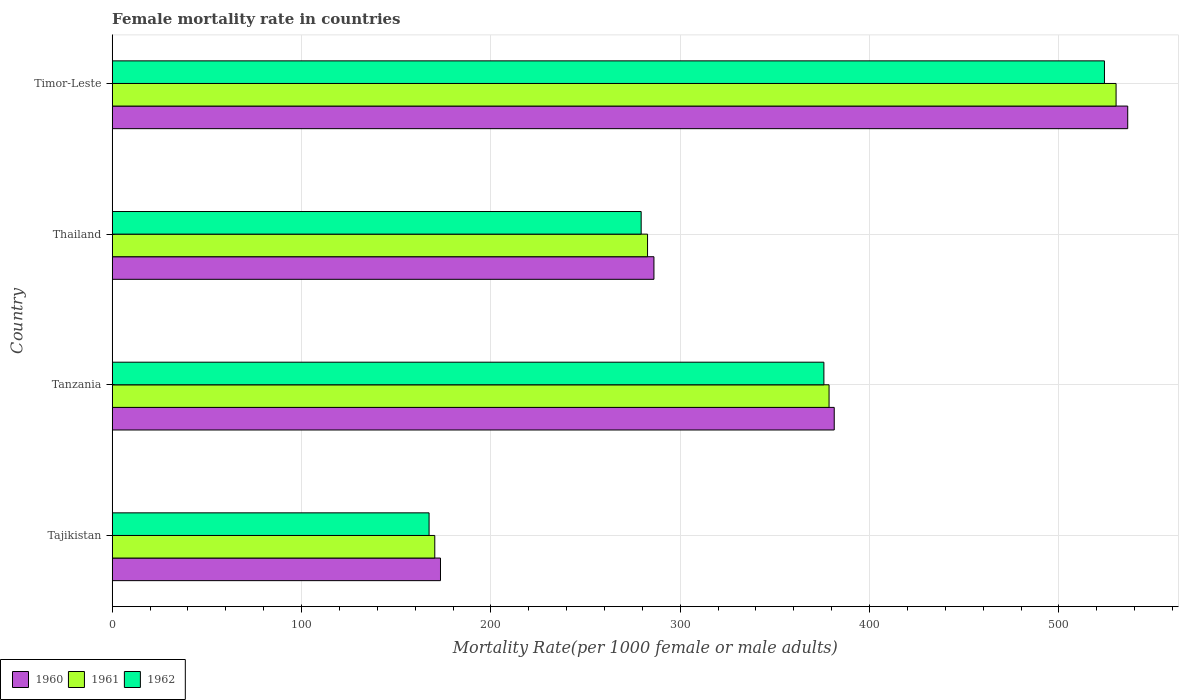How many bars are there on the 2nd tick from the bottom?
Your response must be concise. 3. What is the label of the 2nd group of bars from the top?
Ensure brevity in your answer.  Thailand. What is the female mortality rate in 1962 in Tajikistan?
Provide a short and direct response. 167.34. Across all countries, what is the maximum female mortality rate in 1962?
Your answer should be compact. 524.04. Across all countries, what is the minimum female mortality rate in 1961?
Ensure brevity in your answer.  170.36. In which country was the female mortality rate in 1962 maximum?
Ensure brevity in your answer.  Timor-Leste. In which country was the female mortality rate in 1962 minimum?
Offer a very short reply. Tajikistan. What is the total female mortality rate in 1961 in the graph?
Keep it short and to the point. 1361.87. What is the difference between the female mortality rate in 1962 in Thailand and that in Timor-Leste?
Provide a short and direct response. -244.68. What is the difference between the female mortality rate in 1962 in Timor-Leste and the female mortality rate in 1961 in Tajikistan?
Your answer should be compact. 353.68. What is the average female mortality rate in 1960 per country?
Offer a terse response. 344.28. What is the difference between the female mortality rate in 1962 and female mortality rate in 1960 in Timor-Leste?
Offer a very short reply. -12.29. In how many countries, is the female mortality rate in 1962 greater than 520 ?
Ensure brevity in your answer.  1. What is the ratio of the female mortality rate in 1960 in Tajikistan to that in Timor-Leste?
Provide a succinct answer. 0.32. Is the female mortality rate in 1961 in Tajikistan less than that in Thailand?
Offer a very short reply. Yes. What is the difference between the highest and the second highest female mortality rate in 1961?
Your answer should be compact. 151.59. What is the difference between the highest and the lowest female mortality rate in 1960?
Provide a succinct answer. 362.96. What does the 3rd bar from the top in Tajikistan represents?
Offer a very short reply. 1960. Is it the case that in every country, the sum of the female mortality rate in 1960 and female mortality rate in 1961 is greater than the female mortality rate in 1962?
Provide a succinct answer. Yes. How many countries are there in the graph?
Provide a short and direct response. 4. Are the values on the major ticks of X-axis written in scientific E-notation?
Your answer should be very brief. No. Does the graph contain any zero values?
Make the answer very short. No. How many legend labels are there?
Provide a short and direct response. 3. What is the title of the graph?
Provide a succinct answer. Female mortality rate in countries. What is the label or title of the X-axis?
Offer a very short reply. Mortality Rate(per 1000 female or male adults). What is the Mortality Rate(per 1000 female or male adults) in 1960 in Tajikistan?
Provide a short and direct response. 173.37. What is the Mortality Rate(per 1000 female or male adults) in 1961 in Tajikistan?
Your response must be concise. 170.36. What is the Mortality Rate(per 1000 female or male adults) of 1962 in Tajikistan?
Offer a terse response. 167.34. What is the Mortality Rate(per 1000 female or male adults) in 1960 in Tanzania?
Offer a very short reply. 381.33. What is the Mortality Rate(per 1000 female or male adults) of 1961 in Tanzania?
Your answer should be compact. 378.6. What is the Mortality Rate(per 1000 female or male adults) of 1962 in Tanzania?
Offer a very short reply. 375.87. What is the Mortality Rate(per 1000 female or male adults) of 1960 in Thailand?
Give a very brief answer. 286.1. What is the Mortality Rate(per 1000 female or male adults) of 1961 in Thailand?
Make the answer very short. 282.73. What is the Mortality Rate(per 1000 female or male adults) of 1962 in Thailand?
Your answer should be compact. 279.36. What is the Mortality Rate(per 1000 female or male adults) of 1960 in Timor-Leste?
Offer a terse response. 536.33. What is the Mortality Rate(per 1000 female or male adults) of 1961 in Timor-Leste?
Your response must be concise. 530.18. What is the Mortality Rate(per 1000 female or male adults) of 1962 in Timor-Leste?
Provide a short and direct response. 524.04. Across all countries, what is the maximum Mortality Rate(per 1000 female or male adults) in 1960?
Offer a very short reply. 536.33. Across all countries, what is the maximum Mortality Rate(per 1000 female or male adults) in 1961?
Give a very brief answer. 530.18. Across all countries, what is the maximum Mortality Rate(per 1000 female or male adults) of 1962?
Your answer should be very brief. 524.04. Across all countries, what is the minimum Mortality Rate(per 1000 female or male adults) of 1960?
Keep it short and to the point. 173.37. Across all countries, what is the minimum Mortality Rate(per 1000 female or male adults) in 1961?
Provide a succinct answer. 170.36. Across all countries, what is the minimum Mortality Rate(per 1000 female or male adults) of 1962?
Keep it short and to the point. 167.34. What is the total Mortality Rate(per 1000 female or male adults) in 1960 in the graph?
Your response must be concise. 1377.14. What is the total Mortality Rate(per 1000 female or male adults) in 1961 in the graph?
Your answer should be very brief. 1361.87. What is the total Mortality Rate(per 1000 female or male adults) of 1962 in the graph?
Keep it short and to the point. 1346.6. What is the difference between the Mortality Rate(per 1000 female or male adults) of 1960 in Tajikistan and that in Tanzania?
Make the answer very short. -207.96. What is the difference between the Mortality Rate(per 1000 female or male adults) of 1961 in Tajikistan and that in Tanzania?
Keep it short and to the point. -208.24. What is the difference between the Mortality Rate(per 1000 female or male adults) of 1962 in Tajikistan and that in Tanzania?
Ensure brevity in your answer.  -208.52. What is the difference between the Mortality Rate(per 1000 female or male adults) of 1960 in Tajikistan and that in Thailand?
Keep it short and to the point. -112.73. What is the difference between the Mortality Rate(per 1000 female or male adults) in 1961 in Tajikistan and that in Thailand?
Provide a succinct answer. -112.37. What is the difference between the Mortality Rate(per 1000 female or male adults) of 1962 in Tajikistan and that in Thailand?
Ensure brevity in your answer.  -112.02. What is the difference between the Mortality Rate(per 1000 female or male adults) in 1960 in Tajikistan and that in Timor-Leste?
Offer a terse response. -362.96. What is the difference between the Mortality Rate(per 1000 female or male adults) in 1961 in Tajikistan and that in Timor-Leste?
Your answer should be very brief. -359.83. What is the difference between the Mortality Rate(per 1000 female or male adults) of 1962 in Tajikistan and that in Timor-Leste?
Provide a succinct answer. -356.7. What is the difference between the Mortality Rate(per 1000 female or male adults) in 1960 in Tanzania and that in Thailand?
Your answer should be compact. 95.23. What is the difference between the Mortality Rate(per 1000 female or male adults) in 1961 in Tanzania and that in Thailand?
Ensure brevity in your answer.  95.87. What is the difference between the Mortality Rate(per 1000 female or male adults) in 1962 in Tanzania and that in Thailand?
Provide a succinct answer. 96.51. What is the difference between the Mortality Rate(per 1000 female or male adults) of 1960 in Tanzania and that in Timor-Leste?
Provide a succinct answer. -155. What is the difference between the Mortality Rate(per 1000 female or male adults) of 1961 in Tanzania and that in Timor-Leste?
Your response must be concise. -151.59. What is the difference between the Mortality Rate(per 1000 female or male adults) in 1962 in Tanzania and that in Timor-Leste?
Ensure brevity in your answer.  -148.18. What is the difference between the Mortality Rate(per 1000 female or male adults) of 1960 in Thailand and that in Timor-Leste?
Your answer should be very brief. -250.23. What is the difference between the Mortality Rate(per 1000 female or male adults) in 1961 in Thailand and that in Timor-Leste?
Your response must be concise. -247.45. What is the difference between the Mortality Rate(per 1000 female or male adults) in 1962 in Thailand and that in Timor-Leste?
Offer a very short reply. -244.68. What is the difference between the Mortality Rate(per 1000 female or male adults) of 1960 in Tajikistan and the Mortality Rate(per 1000 female or male adults) of 1961 in Tanzania?
Ensure brevity in your answer.  -205.22. What is the difference between the Mortality Rate(per 1000 female or male adults) in 1960 in Tajikistan and the Mortality Rate(per 1000 female or male adults) in 1962 in Tanzania?
Keep it short and to the point. -202.49. What is the difference between the Mortality Rate(per 1000 female or male adults) of 1961 in Tajikistan and the Mortality Rate(per 1000 female or male adults) of 1962 in Tanzania?
Your answer should be very brief. -205.51. What is the difference between the Mortality Rate(per 1000 female or male adults) of 1960 in Tajikistan and the Mortality Rate(per 1000 female or male adults) of 1961 in Thailand?
Ensure brevity in your answer.  -109.36. What is the difference between the Mortality Rate(per 1000 female or male adults) of 1960 in Tajikistan and the Mortality Rate(per 1000 female or male adults) of 1962 in Thailand?
Give a very brief answer. -105.98. What is the difference between the Mortality Rate(per 1000 female or male adults) in 1961 in Tajikistan and the Mortality Rate(per 1000 female or male adults) in 1962 in Thailand?
Keep it short and to the point. -109. What is the difference between the Mortality Rate(per 1000 female or male adults) of 1960 in Tajikistan and the Mortality Rate(per 1000 female or male adults) of 1961 in Timor-Leste?
Your answer should be very brief. -356.81. What is the difference between the Mortality Rate(per 1000 female or male adults) in 1960 in Tajikistan and the Mortality Rate(per 1000 female or male adults) in 1962 in Timor-Leste?
Offer a very short reply. -350.67. What is the difference between the Mortality Rate(per 1000 female or male adults) of 1961 in Tajikistan and the Mortality Rate(per 1000 female or male adults) of 1962 in Timor-Leste?
Provide a short and direct response. -353.68. What is the difference between the Mortality Rate(per 1000 female or male adults) of 1960 in Tanzania and the Mortality Rate(per 1000 female or male adults) of 1961 in Thailand?
Your response must be concise. 98.6. What is the difference between the Mortality Rate(per 1000 female or male adults) in 1960 in Tanzania and the Mortality Rate(per 1000 female or male adults) in 1962 in Thailand?
Your response must be concise. 101.97. What is the difference between the Mortality Rate(per 1000 female or male adults) in 1961 in Tanzania and the Mortality Rate(per 1000 female or male adults) in 1962 in Thailand?
Make the answer very short. 99.24. What is the difference between the Mortality Rate(per 1000 female or male adults) of 1960 in Tanzania and the Mortality Rate(per 1000 female or male adults) of 1961 in Timor-Leste?
Provide a short and direct response. -148.85. What is the difference between the Mortality Rate(per 1000 female or male adults) in 1960 in Tanzania and the Mortality Rate(per 1000 female or male adults) in 1962 in Timor-Leste?
Provide a succinct answer. -142.71. What is the difference between the Mortality Rate(per 1000 female or male adults) in 1961 in Tanzania and the Mortality Rate(per 1000 female or male adults) in 1962 in Timor-Leste?
Make the answer very short. -145.44. What is the difference between the Mortality Rate(per 1000 female or male adults) in 1960 in Thailand and the Mortality Rate(per 1000 female or male adults) in 1961 in Timor-Leste?
Provide a short and direct response. -244.08. What is the difference between the Mortality Rate(per 1000 female or male adults) of 1960 in Thailand and the Mortality Rate(per 1000 female or male adults) of 1962 in Timor-Leste?
Keep it short and to the point. -237.94. What is the difference between the Mortality Rate(per 1000 female or male adults) in 1961 in Thailand and the Mortality Rate(per 1000 female or male adults) in 1962 in Timor-Leste?
Give a very brief answer. -241.31. What is the average Mortality Rate(per 1000 female or male adults) of 1960 per country?
Ensure brevity in your answer.  344.28. What is the average Mortality Rate(per 1000 female or male adults) in 1961 per country?
Give a very brief answer. 340.47. What is the average Mortality Rate(per 1000 female or male adults) in 1962 per country?
Keep it short and to the point. 336.65. What is the difference between the Mortality Rate(per 1000 female or male adults) in 1960 and Mortality Rate(per 1000 female or male adults) in 1961 in Tajikistan?
Keep it short and to the point. 3.02. What is the difference between the Mortality Rate(per 1000 female or male adults) in 1960 and Mortality Rate(per 1000 female or male adults) in 1962 in Tajikistan?
Offer a very short reply. 6.03. What is the difference between the Mortality Rate(per 1000 female or male adults) of 1961 and Mortality Rate(per 1000 female or male adults) of 1962 in Tajikistan?
Give a very brief answer. 3.02. What is the difference between the Mortality Rate(per 1000 female or male adults) of 1960 and Mortality Rate(per 1000 female or male adults) of 1961 in Tanzania?
Give a very brief answer. 2.73. What is the difference between the Mortality Rate(per 1000 female or male adults) in 1960 and Mortality Rate(per 1000 female or male adults) in 1962 in Tanzania?
Offer a very short reply. 5.46. What is the difference between the Mortality Rate(per 1000 female or male adults) of 1961 and Mortality Rate(per 1000 female or male adults) of 1962 in Tanzania?
Your answer should be very brief. 2.73. What is the difference between the Mortality Rate(per 1000 female or male adults) in 1960 and Mortality Rate(per 1000 female or male adults) in 1961 in Thailand?
Your response must be concise. 3.37. What is the difference between the Mortality Rate(per 1000 female or male adults) in 1960 and Mortality Rate(per 1000 female or male adults) in 1962 in Thailand?
Provide a succinct answer. 6.75. What is the difference between the Mortality Rate(per 1000 female or male adults) in 1961 and Mortality Rate(per 1000 female or male adults) in 1962 in Thailand?
Your response must be concise. 3.37. What is the difference between the Mortality Rate(per 1000 female or male adults) in 1960 and Mortality Rate(per 1000 female or male adults) in 1961 in Timor-Leste?
Offer a terse response. 6.14. What is the difference between the Mortality Rate(per 1000 female or male adults) of 1960 and Mortality Rate(per 1000 female or male adults) of 1962 in Timor-Leste?
Offer a very short reply. 12.29. What is the difference between the Mortality Rate(per 1000 female or male adults) of 1961 and Mortality Rate(per 1000 female or male adults) of 1962 in Timor-Leste?
Make the answer very short. 6.14. What is the ratio of the Mortality Rate(per 1000 female or male adults) in 1960 in Tajikistan to that in Tanzania?
Ensure brevity in your answer.  0.45. What is the ratio of the Mortality Rate(per 1000 female or male adults) in 1961 in Tajikistan to that in Tanzania?
Your response must be concise. 0.45. What is the ratio of the Mortality Rate(per 1000 female or male adults) in 1962 in Tajikistan to that in Tanzania?
Your answer should be compact. 0.45. What is the ratio of the Mortality Rate(per 1000 female or male adults) in 1960 in Tajikistan to that in Thailand?
Your answer should be very brief. 0.61. What is the ratio of the Mortality Rate(per 1000 female or male adults) in 1961 in Tajikistan to that in Thailand?
Your response must be concise. 0.6. What is the ratio of the Mortality Rate(per 1000 female or male adults) of 1962 in Tajikistan to that in Thailand?
Provide a short and direct response. 0.6. What is the ratio of the Mortality Rate(per 1000 female or male adults) of 1960 in Tajikistan to that in Timor-Leste?
Keep it short and to the point. 0.32. What is the ratio of the Mortality Rate(per 1000 female or male adults) in 1961 in Tajikistan to that in Timor-Leste?
Your response must be concise. 0.32. What is the ratio of the Mortality Rate(per 1000 female or male adults) in 1962 in Tajikistan to that in Timor-Leste?
Offer a terse response. 0.32. What is the ratio of the Mortality Rate(per 1000 female or male adults) of 1960 in Tanzania to that in Thailand?
Make the answer very short. 1.33. What is the ratio of the Mortality Rate(per 1000 female or male adults) in 1961 in Tanzania to that in Thailand?
Make the answer very short. 1.34. What is the ratio of the Mortality Rate(per 1000 female or male adults) in 1962 in Tanzania to that in Thailand?
Your answer should be compact. 1.35. What is the ratio of the Mortality Rate(per 1000 female or male adults) in 1960 in Tanzania to that in Timor-Leste?
Provide a short and direct response. 0.71. What is the ratio of the Mortality Rate(per 1000 female or male adults) of 1961 in Tanzania to that in Timor-Leste?
Provide a short and direct response. 0.71. What is the ratio of the Mortality Rate(per 1000 female or male adults) of 1962 in Tanzania to that in Timor-Leste?
Provide a short and direct response. 0.72. What is the ratio of the Mortality Rate(per 1000 female or male adults) of 1960 in Thailand to that in Timor-Leste?
Offer a terse response. 0.53. What is the ratio of the Mortality Rate(per 1000 female or male adults) of 1961 in Thailand to that in Timor-Leste?
Ensure brevity in your answer.  0.53. What is the ratio of the Mortality Rate(per 1000 female or male adults) of 1962 in Thailand to that in Timor-Leste?
Keep it short and to the point. 0.53. What is the difference between the highest and the second highest Mortality Rate(per 1000 female or male adults) in 1960?
Make the answer very short. 155. What is the difference between the highest and the second highest Mortality Rate(per 1000 female or male adults) in 1961?
Provide a succinct answer. 151.59. What is the difference between the highest and the second highest Mortality Rate(per 1000 female or male adults) of 1962?
Make the answer very short. 148.18. What is the difference between the highest and the lowest Mortality Rate(per 1000 female or male adults) in 1960?
Offer a terse response. 362.96. What is the difference between the highest and the lowest Mortality Rate(per 1000 female or male adults) in 1961?
Your response must be concise. 359.83. What is the difference between the highest and the lowest Mortality Rate(per 1000 female or male adults) of 1962?
Make the answer very short. 356.7. 